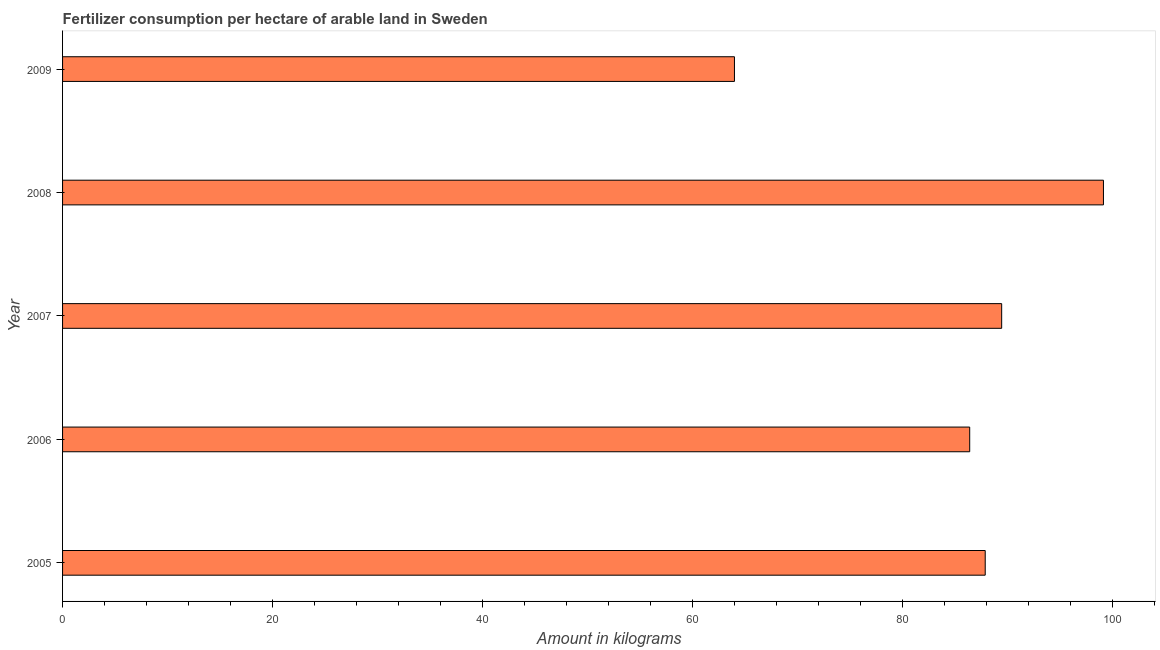Does the graph contain any zero values?
Ensure brevity in your answer.  No. What is the title of the graph?
Your answer should be compact. Fertilizer consumption per hectare of arable land in Sweden . What is the label or title of the X-axis?
Your answer should be compact. Amount in kilograms. What is the amount of fertilizer consumption in 2009?
Provide a succinct answer. 64.01. Across all years, what is the maximum amount of fertilizer consumption?
Your response must be concise. 99.16. Across all years, what is the minimum amount of fertilizer consumption?
Provide a short and direct response. 64.01. In which year was the amount of fertilizer consumption minimum?
Provide a succinct answer. 2009. What is the sum of the amount of fertilizer consumption?
Provide a short and direct response. 426.96. What is the difference between the amount of fertilizer consumption in 2006 and 2007?
Provide a short and direct response. -3.04. What is the average amount of fertilizer consumption per year?
Your response must be concise. 85.39. What is the median amount of fertilizer consumption?
Your answer should be very brief. 87.9. What is the ratio of the amount of fertilizer consumption in 2007 to that in 2009?
Offer a very short reply. 1.4. Is the difference between the amount of fertilizer consumption in 2007 and 2009 greater than the difference between any two years?
Your answer should be compact. No. What is the difference between the highest and the second highest amount of fertilizer consumption?
Your response must be concise. 9.7. What is the difference between the highest and the lowest amount of fertilizer consumption?
Ensure brevity in your answer.  35.15. In how many years, is the amount of fertilizer consumption greater than the average amount of fertilizer consumption taken over all years?
Offer a terse response. 4. How many bars are there?
Ensure brevity in your answer.  5. Are the values on the major ticks of X-axis written in scientific E-notation?
Offer a very short reply. No. What is the Amount in kilograms in 2005?
Make the answer very short. 87.9. What is the Amount in kilograms of 2006?
Offer a terse response. 86.42. What is the Amount in kilograms of 2007?
Keep it short and to the point. 89.47. What is the Amount in kilograms of 2008?
Keep it short and to the point. 99.16. What is the Amount in kilograms in 2009?
Make the answer very short. 64.01. What is the difference between the Amount in kilograms in 2005 and 2006?
Provide a succinct answer. 1.48. What is the difference between the Amount in kilograms in 2005 and 2007?
Your answer should be very brief. -1.57. What is the difference between the Amount in kilograms in 2005 and 2008?
Your answer should be compact. -11.26. What is the difference between the Amount in kilograms in 2005 and 2009?
Your response must be concise. 23.89. What is the difference between the Amount in kilograms in 2006 and 2007?
Your answer should be compact. -3.05. What is the difference between the Amount in kilograms in 2006 and 2008?
Your answer should be very brief. -12.74. What is the difference between the Amount in kilograms in 2006 and 2009?
Make the answer very short. 22.41. What is the difference between the Amount in kilograms in 2007 and 2008?
Offer a terse response. -9.7. What is the difference between the Amount in kilograms in 2007 and 2009?
Provide a short and direct response. 25.46. What is the difference between the Amount in kilograms in 2008 and 2009?
Give a very brief answer. 35.15. What is the ratio of the Amount in kilograms in 2005 to that in 2006?
Offer a terse response. 1.02. What is the ratio of the Amount in kilograms in 2005 to that in 2007?
Your answer should be very brief. 0.98. What is the ratio of the Amount in kilograms in 2005 to that in 2008?
Your answer should be very brief. 0.89. What is the ratio of the Amount in kilograms in 2005 to that in 2009?
Offer a very short reply. 1.37. What is the ratio of the Amount in kilograms in 2006 to that in 2008?
Your response must be concise. 0.87. What is the ratio of the Amount in kilograms in 2006 to that in 2009?
Ensure brevity in your answer.  1.35. What is the ratio of the Amount in kilograms in 2007 to that in 2008?
Provide a succinct answer. 0.9. What is the ratio of the Amount in kilograms in 2007 to that in 2009?
Offer a very short reply. 1.4. What is the ratio of the Amount in kilograms in 2008 to that in 2009?
Provide a short and direct response. 1.55. 